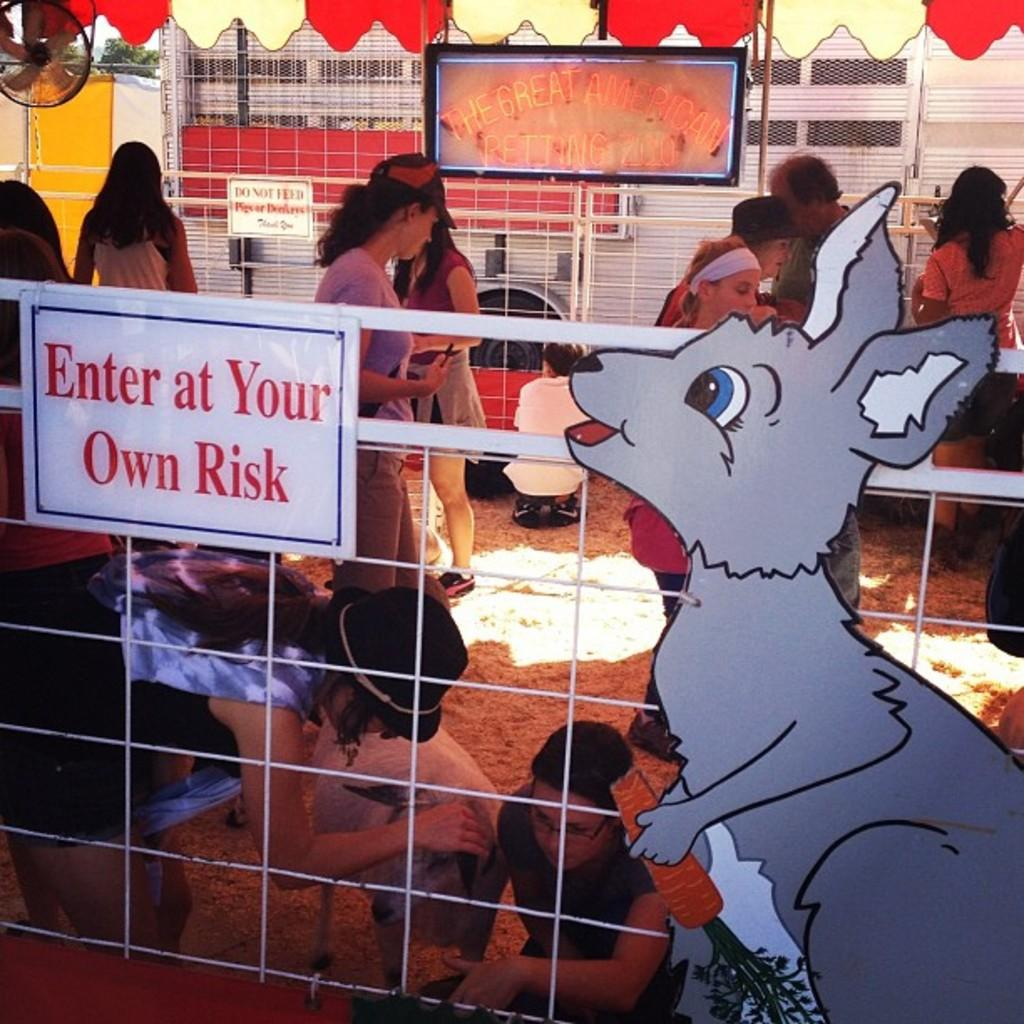What is present in the image that separates the groups of people? There is a fence in the image that separates the groups of people. What is attached to the fence? There is a board on the fence. Can you describe the people in the image? There are groups of people behind the fence, and they are accompanied by an animal. What is visible behind the people? There is a board visible behind the people, and there is also a wall behind them. What decision does the animal make in the image? There is no indication in the image that the animal is making a decision, as animals do not have the ability to make decisions in the same way humans do. 